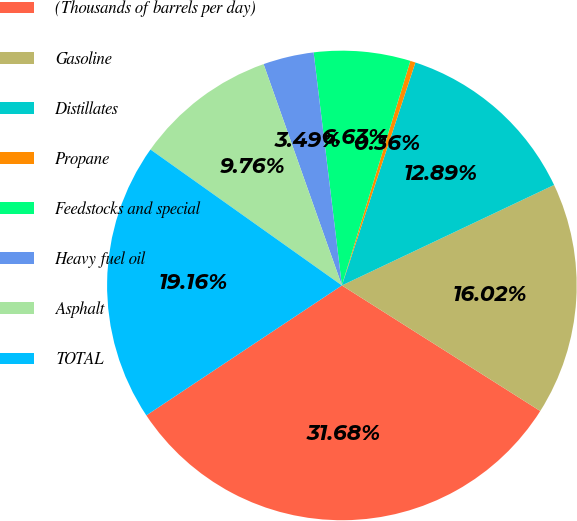Convert chart. <chart><loc_0><loc_0><loc_500><loc_500><pie_chart><fcel>(Thousands of barrels per day)<fcel>Gasoline<fcel>Distillates<fcel>Propane<fcel>Feedstocks and special<fcel>Heavy fuel oil<fcel>Asphalt<fcel>TOTAL<nl><fcel>31.68%<fcel>16.02%<fcel>12.89%<fcel>0.36%<fcel>6.63%<fcel>3.49%<fcel>9.76%<fcel>19.16%<nl></chart> 